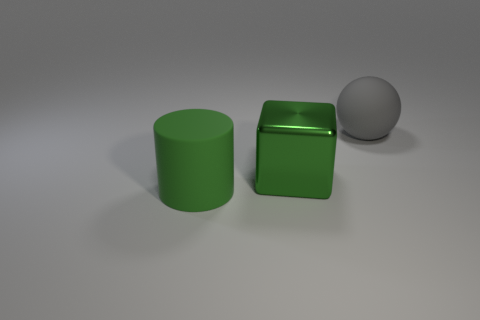What material is the gray ball that is behind the rubber thing in front of the big block made of? rubber 